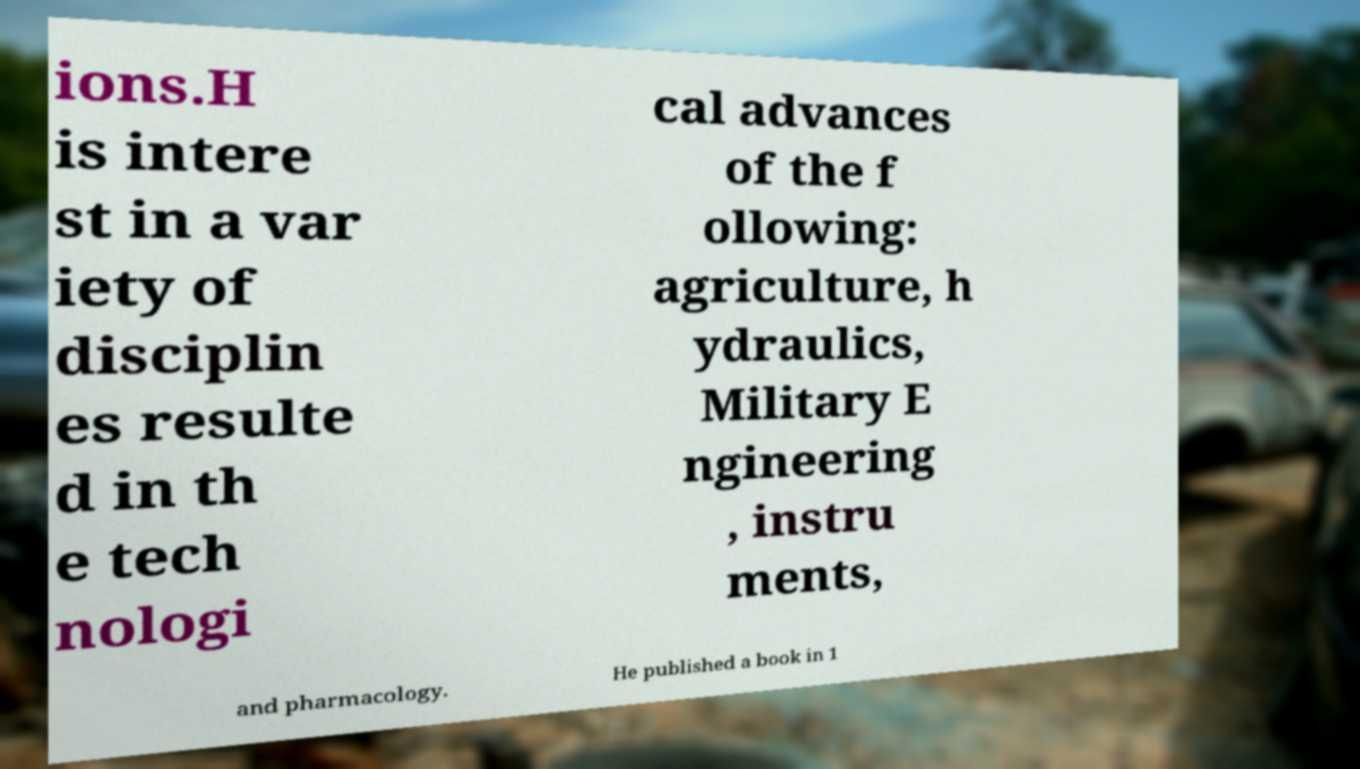For documentation purposes, I need the text within this image transcribed. Could you provide that? ions.H is intere st in a var iety of disciplin es resulte d in th e tech nologi cal advances of the f ollowing: agriculture, h ydraulics, Military E ngineering , instru ments, and pharmacology. He published a book in 1 